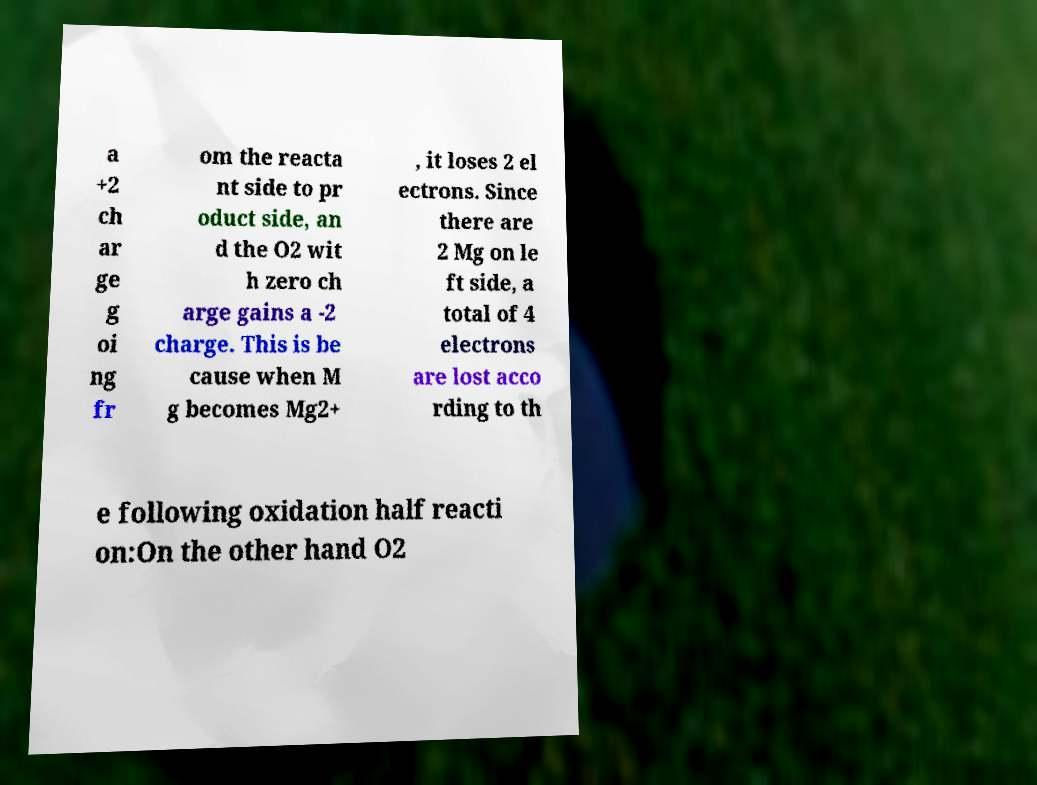Please identify and transcribe the text found in this image. a +2 ch ar ge g oi ng fr om the reacta nt side to pr oduct side, an d the O2 wit h zero ch arge gains a -2 charge. This is be cause when M g becomes Mg2+ , it loses 2 el ectrons. Since there are 2 Mg on le ft side, a total of 4 electrons are lost acco rding to th e following oxidation half reacti on:On the other hand O2 